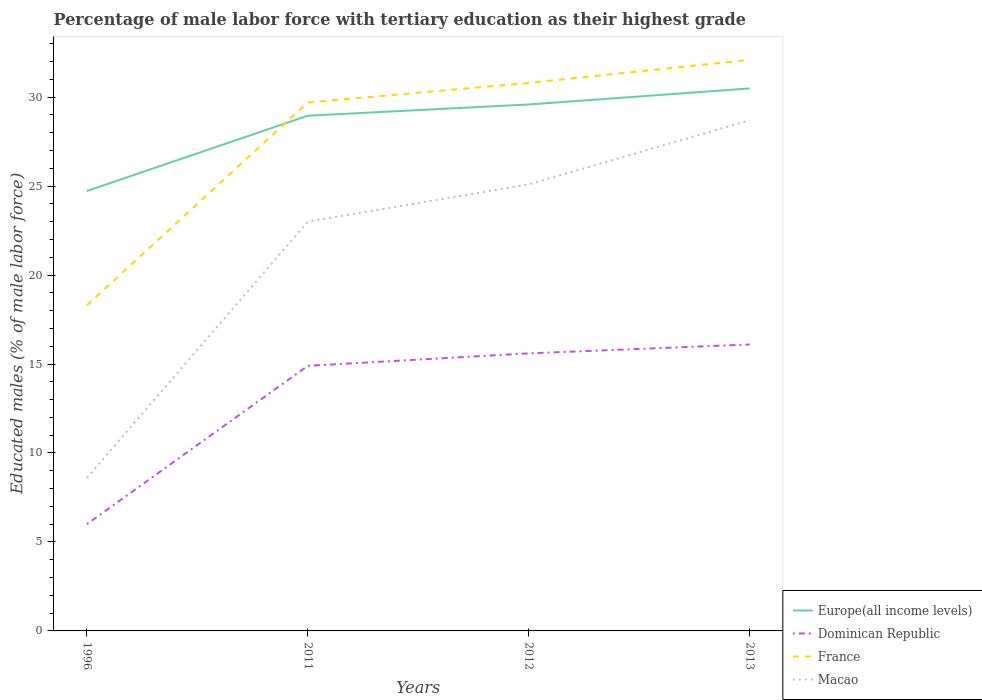Does the line corresponding to Dominican Republic intersect with the line corresponding to France?
Your answer should be compact. No. Across all years, what is the maximum percentage of male labor force with tertiary education in Europe(all income levels)?
Give a very brief answer. 24.72. What is the total percentage of male labor force with tertiary education in France in the graph?
Offer a very short reply. -1.3. What is the difference between the highest and the second highest percentage of male labor force with tertiary education in Dominican Republic?
Your answer should be very brief. 10.1. Is the percentage of male labor force with tertiary education in Dominican Republic strictly greater than the percentage of male labor force with tertiary education in Europe(all income levels) over the years?
Provide a short and direct response. Yes. How many lines are there?
Your answer should be very brief. 4. How many years are there in the graph?
Provide a short and direct response. 4. What is the difference between two consecutive major ticks on the Y-axis?
Your answer should be very brief. 5. Are the values on the major ticks of Y-axis written in scientific E-notation?
Provide a succinct answer. No. Does the graph contain any zero values?
Make the answer very short. No. Where does the legend appear in the graph?
Your answer should be very brief. Bottom right. How many legend labels are there?
Provide a short and direct response. 4. How are the legend labels stacked?
Offer a very short reply. Vertical. What is the title of the graph?
Offer a very short reply. Percentage of male labor force with tertiary education as their highest grade. What is the label or title of the Y-axis?
Your answer should be very brief. Educated males (% of male labor force). What is the Educated males (% of male labor force) in Europe(all income levels) in 1996?
Keep it short and to the point. 24.72. What is the Educated males (% of male labor force) of France in 1996?
Make the answer very short. 18.3. What is the Educated males (% of male labor force) of Macao in 1996?
Make the answer very short. 8.6. What is the Educated males (% of male labor force) in Europe(all income levels) in 2011?
Offer a terse response. 28.96. What is the Educated males (% of male labor force) of Dominican Republic in 2011?
Offer a very short reply. 14.9. What is the Educated males (% of male labor force) in France in 2011?
Provide a succinct answer. 29.7. What is the Educated males (% of male labor force) in Europe(all income levels) in 2012?
Provide a short and direct response. 29.59. What is the Educated males (% of male labor force) in Dominican Republic in 2012?
Your answer should be very brief. 15.6. What is the Educated males (% of male labor force) in France in 2012?
Offer a terse response. 30.8. What is the Educated males (% of male labor force) of Macao in 2012?
Make the answer very short. 25.1. What is the Educated males (% of male labor force) of Europe(all income levels) in 2013?
Your answer should be compact. 30.49. What is the Educated males (% of male labor force) of Dominican Republic in 2013?
Make the answer very short. 16.1. What is the Educated males (% of male labor force) in France in 2013?
Provide a succinct answer. 32.1. What is the Educated males (% of male labor force) in Macao in 2013?
Offer a terse response. 28.7. Across all years, what is the maximum Educated males (% of male labor force) of Europe(all income levels)?
Provide a short and direct response. 30.49. Across all years, what is the maximum Educated males (% of male labor force) of Dominican Republic?
Keep it short and to the point. 16.1. Across all years, what is the maximum Educated males (% of male labor force) of France?
Ensure brevity in your answer.  32.1. Across all years, what is the maximum Educated males (% of male labor force) in Macao?
Your response must be concise. 28.7. Across all years, what is the minimum Educated males (% of male labor force) of Europe(all income levels)?
Make the answer very short. 24.72. Across all years, what is the minimum Educated males (% of male labor force) of France?
Make the answer very short. 18.3. Across all years, what is the minimum Educated males (% of male labor force) of Macao?
Ensure brevity in your answer.  8.6. What is the total Educated males (% of male labor force) in Europe(all income levels) in the graph?
Ensure brevity in your answer.  113.76. What is the total Educated males (% of male labor force) in Dominican Republic in the graph?
Ensure brevity in your answer.  52.6. What is the total Educated males (% of male labor force) in France in the graph?
Your response must be concise. 110.9. What is the total Educated males (% of male labor force) of Macao in the graph?
Offer a terse response. 85.4. What is the difference between the Educated males (% of male labor force) of Europe(all income levels) in 1996 and that in 2011?
Your answer should be compact. -4.23. What is the difference between the Educated males (% of male labor force) in France in 1996 and that in 2011?
Offer a very short reply. -11.4. What is the difference between the Educated males (% of male labor force) in Macao in 1996 and that in 2011?
Make the answer very short. -14.4. What is the difference between the Educated males (% of male labor force) of Europe(all income levels) in 1996 and that in 2012?
Your response must be concise. -4.87. What is the difference between the Educated males (% of male labor force) in Dominican Republic in 1996 and that in 2012?
Offer a terse response. -9.6. What is the difference between the Educated males (% of male labor force) of Macao in 1996 and that in 2012?
Your answer should be compact. -16.5. What is the difference between the Educated males (% of male labor force) of Europe(all income levels) in 1996 and that in 2013?
Your response must be concise. -5.76. What is the difference between the Educated males (% of male labor force) of Dominican Republic in 1996 and that in 2013?
Provide a short and direct response. -10.1. What is the difference between the Educated males (% of male labor force) in Macao in 1996 and that in 2013?
Keep it short and to the point. -20.1. What is the difference between the Educated males (% of male labor force) in Europe(all income levels) in 2011 and that in 2012?
Your answer should be compact. -0.63. What is the difference between the Educated males (% of male labor force) of Dominican Republic in 2011 and that in 2012?
Your response must be concise. -0.7. What is the difference between the Educated males (% of male labor force) in Macao in 2011 and that in 2012?
Keep it short and to the point. -2.1. What is the difference between the Educated males (% of male labor force) of Europe(all income levels) in 2011 and that in 2013?
Give a very brief answer. -1.53. What is the difference between the Educated males (% of male labor force) in Europe(all income levels) in 2012 and that in 2013?
Provide a succinct answer. -0.9. What is the difference between the Educated males (% of male labor force) in Dominican Republic in 2012 and that in 2013?
Make the answer very short. -0.5. What is the difference between the Educated males (% of male labor force) in Europe(all income levels) in 1996 and the Educated males (% of male labor force) in Dominican Republic in 2011?
Your response must be concise. 9.82. What is the difference between the Educated males (% of male labor force) of Europe(all income levels) in 1996 and the Educated males (% of male labor force) of France in 2011?
Your response must be concise. -4.98. What is the difference between the Educated males (% of male labor force) in Europe(all income levels) in 1996 and the Educated males (% of male labor force) in Macao in 2011?
Provide a short and direct response. 1.72. What is the difference between the Educated males (% of male labor force) of Dominican Republic in 1996 and the Educated males (% of male labor force) of France in 2011?
Your answer should be compact. -23.7. What is the difference between the Educated males (% of male labor force) in Dominican Republic in 1996 and the Educated males (% of male labor force) in Macao in 2011?
Your response must be concise. -17. What is the difference between the Educated males (% of male labor force) in France in 1996 and the Educated males (% of male labor force) in Macao in 2011?
Ensure brevity in your answer.  -4.7. What is the difference between the Educated males (% of male labor force) of Europe(all income levels) in 1996 and the Educated males (% of male labor force) of Dominican Republic in 2012?
Keep it short and to the point. 9.12. What is the difference between the Educated males (% of male labor force) of Europe(all income levels) in 1996 and the Educated males (% of male labor force) of France in 2012?
Your response must be concise. -6.08. What is the difference between the Educated males (% of male labor force) of Europe(all income levels) in 1996 and the Educated males (% of male labor force) of Macao in 2012?
Your response must be concise. -0.38. What is the difference between the Educated males (% of male labor force) in Dominican Republic in 1996 and the Educated males (% of male labor force) in France in 2012?
Give a very brief answer. -24.8. What is the difference between the Educated males (% of male labor force) of Dominican Republic in 1996 and the Educated males (% of male labor force) of Macao in 2012?
Give a very brief answer. -19.1. What is the difference between the Educated males (% of male labor force) of Europe(all income levels) in 1996 and the Educated males (% of male labor force) of Dominican Republic in 2013?
Your answer should be compact. 8.62. What is the difference between the Educated males (% of male labor force) in Europe(all income levels) in 1996 and the Educated males (% of male labor force) in France in 2013?
Provide a succinct answer. -7.38. What is the difference between the Educated males (% of male labor force) of Europe(all income levels) in 1996 and the Educated males (% of male labor force) of Macao in 2013?
Offer a very short reply. -3.98. What is the difference between the Educated males (% of male labor force) of Dominican Republic in 1996 and the Educated males (% of male labor force) of France in 2013?
Your answer should be very brief. -26.1. What is the difference between the Educated males (% of male labor force) in Dominican Republic in 1996 and the Educated males (% of male labor force) in Macao in 2013?
Provide a succinct answer. -22.7. What is the difference between the Educated males (% of male labor force) in France in 1996 and the Educated males (% of male labor force) in Macao in 2013?
Offer a terse response. -10.4. What is the difference between the Educated males (% of male labor force) in Europe(all income levels) in 2011 and the Educated males (% of male labor force) in Dominican Republic in 2012?
Keep it short and to the point. 13.36. What is the difference between the Educated males (% of male labor force) in Europe(all income levels) in 2011 and the Educated males (% of male labor force) in France in 2012?
Offer a very short reply. -1.84. What is the difference between the Educated males (% of male labor force) of Europe(all income levels) in 2011 and the Educated males (% of male labor force) of Macao in 2012?
Offer a terse response. 3.86. What is the difference between the Educated males (% of male labor force) in Dominican Republic in 2011 and the Educated males (% of male labor force) in France in 2012?
Offer a very short reply. -15.9. What is the difference between the Educated males (% of male labor force) of Dominican Republic in 2011 and the Educated males (% of male labor force) of Macao in 2012?
Provide a succinct answer. -10.2. What is the difference between the Educated males (% of male labor force) in France in 2011 and the Educated males (% of male labor force) in Macao in 2012?
Offer a very short reply. 4.6. What is the difference between the Educated males (% of male labor force) of Europe(all income levels) in 2011 and the Educated males (% of male labor force) of Dominican Republic in 2013?
Your answer should be compact. 12.86. What is the difference between the Educated males (% of male labor force) in Europe(all income levels) in 2011 and the Educated males (% of male labor force) in France in 2013?
Give a very brief answer. -3.14. What is the difference between the Educated males (% of male labor force) in Europe(all income levels) in 2011 and the Educated males (% of male labor force) in Macao in 2013?
Make the answer very short. 0.26. What is the difference between the Educated males (% of male labor force) in Dominican Republic in 2011 and the Educated males (% of male labor force) in France in 2013?
Offer a very short reply. -17.2. What is the difference between the Educated males (% of male labor force) in Dominican Republic in 2011 and the Educated males (% of male labor force) in Macao in 2013?
Ensure brevity in your answer.  -13.8. What is the difference between the Educated males (% of male labor force) of France in 2011 and the Educated males (% of male labor force) of Macao in 2013?
Your answer should be compact. 1. What is the difference between the Educated males (% of male labor force) in Europe(all income levels) in 2012 and the Educated males (% of male labor force) in Dominican Republic in 2013?
Offer a terse response. 13.49. What is the difference between the Educated males (% of male labor force) of Europe(all income levels) in 2012 and the Educated males (% of male labor force) of France in 2013?
Offer a very short reply. -2.51. What is the difference between the Educated males (% of male labor force) in Europe(all income levels) in 2012 and the Educated males (% of male labor force) in Macao in 2013?
Your answer should be very brief. 0.89. What is the difference between the Educated males (% of male labor force) in Dominican Republic in 2012 and the Educated males (% of male labor force) in France in 2013?
Give a very brief answer. -16.5. What is the difference between the Educated males (% of male labor force) of Dominican Republic in 2012 and the Educated males (% of male labor force) of Macao in 2013?
Your answer should be compact. -13.1. What is the average Educated males (% of male labor force) of Europe(all income levels) per year?
Offer a terse response. 28.44. What is the average Educated males (% of male labor force) of Dominican Republic per year?
Provide a short and direct response. 13.15. What is the average Educated males (% of male labor force) of France per year?
Give a very brief answer. 27.73. What is the average Educated males (% of male labor force) in Macao per year?
Give a very brief answer. 21.35. In the year 1996, what is the difference between the Educated males (% of male labor force) in Europe(all income levels) and Educated males (% of male labor force) in Dominican Republic?
Your answer should be very brief. 18.72. In the year 1996, what is the difference between the Educated males (% of male labor force) in Europe(all income levels) and Educated males (% of male labor force) in France?
Your answer should be very brief. 6.42. In the year 1996, what is the difference between the Educated males (% of male labor force) of Europe(all income levels) and Educated males (% of male labor force) of Macao?
Ensure brevity in your answer.  16.12. In the year 1996, what is the difference between the Educated males (% of male labor force) of France and Educated males (% of male labor force) of Macao?
Provide a succinct answer. 9.7. In the year 2011, what is the difference between the Educated males (% of male labor force) of Europe(all income levels) and Educated males (% of male labor force) of Dominican Republic?
Ensure brevity in your answer.  14.06. In the year 2011, what is the difference between the Educated males (% of male labor force) of Europe(all income levels) and Educated males (% of male labor force) of France?
Provide a short and direct response. -0.74. In the year 2011, what is the difference between the Educated males (% of male labor force) in Europe(all income levels) and Educated males (% of male labor force) in Macao?
Offer a very short reply. 5.96. In the year 2011, what is the difference between the Educated males (% of male labor force) of Dominican Republic and Educated males (% of male labor force) of France?
Offer a terse response. -14.8. In the year 2011, what is the difference between the Educated males (% of male labor force) in Dominican Republic and Educated males (% of male labor force) in Macao?
Offer a very short reply. -8.1. In the year 2011, what is the difference between the Educated males (% of male labor force) in France and Educated males (% of male labor force) in Macao?
Ensure brevity in your answer.  6.7. In the year 2012, what is the difference between the Educated males (% of male labor force) in Europe(all income levels) and Educated males (% of male labor force) in Dominican Republic?
Provide a short and direct response. 13.99. In the year 2012, what is the difference between the Educated males (% of male labor force) in Europe(all income levels) and Educated males (% of male labor force) in France?
Your response must be concise. -1.21. In the year 2012, what is the difference between the Educated males (% of male labor force) of Europe(all income levels) and Educated males (% of male labor force) of Macao?
Ensure brevity in your answer.  4.49. In the year 2012, what is the difference between the Educated males (% of male labor force) in Dominican Republic and Educated males (% of male labor force) in France?
Offer a very short reply. -15.2. In the year 2013, what is the difference between the Educated males (% of male labor force) of Europe(all income levels) and Educated males (% of male labor force) of Dominican Republic?
Give a very brief answer. 14.39. In the year 2013, what is the difference between the Educated males (% of male labor force) in Europe(all income levels) and Educated males (% of male labor force) in France?
Your answer should be very brief. -1.61. In the year 2013, what is the difference between the Educated males (% of male labor force) of Europe(all income levels) and Educated males (% of male labor force) of Macao?
Ensure brevity in your answer.  1.79. In the year 2013, what is the difference between the Educated males (% of male labor force) of Dominican Republic and Educated males (% of male labor force) of France?
Offer a very short reply. -16. In the year 2013, what is the difference between the Educated males (% of male labor force) in Dominican Republic and Educated males (% of male labor force) in Macao?
Give a very brief answer. -12.6. What is the ratio of the Educated males (% of male labor force) of Europe(all income levels) in 1996 to that in 2011?
Offer a terse response. 0.85. What is the ratio of the Educated males (% of male labor force) of Dominican Republic in 1996 to that in 2011?
Ensure brevity in your answer.  0.4. What is the ratio of the Educated males (% of male labor force) of France in 1996 to that in 2011?
Your answer should be compact. 0.62. What is the ratio of the Educated males (% of male labor force) in Macao in 1996 to that in 2011?
Ensure brevity in your answer.  0.37. What is the ratio of the Educated males (% of male labor force) of Europe(all income levels) in 1996 to that in 2012?
Ensure brevity in your answer.  0.84. What is the ratio of the Educated males (% of male labor force) in Dominican Republic in 1996 to that in 2012?
Your answer should be compact. 0.38. What is the ratio of the Educated males (% of male labor force) in France in 1996 to that in 2012?
Give a very brief answer. 0.59. What is the ratio of the Educated males (% of male labor force) of Macao in 1996 to that in 2012?
Offer a very short reply. 0.34. What is the ratio of the Educated males (% of male labor force) of Europe(all income levels) in 1996 to that in 2013?
Offer a terse response. 0.81. What is the ratio of the Educated males (% of male labor force) in Dominican Republic in 1996 to that in 2013?
Give a very brief answer. 0.37. What is the ratio of the Educated males (% of male labor force) in France in 1996 to that in 2013?
Give a very brief answer. 0.57. What is the ratio of the Educated males (% of male labor force) of Macao in 1996 to that in 2013?
Offer a very short reply. 0.3. What is the ratio of the Educated males (% of male labor force) in Europe(all income levels) in 2011 to that in 2012?
Offer a terse response. 0.98. What is the ratio of the Educated males (% of male labor force) in Dominican Republic in 2011 to that in 2012?
Your response must be concise. 0.96. What is the ratio of the Educated males (% of male labor force) of France in 2011 to that in 2012?
Give a very brief answer. 0.96. What is the ratio of the Educated males (% of male labor force) in Macao in 2011 to that in 2012?
Provide a succinct answer. 0.92. What is the ratio of the Educated males (% of male labor force) of Europe(all income levels) in 2011 to that in 2013?
Provide a succinct answer. 0.95. What is the ratio of the Educated males (% of male labor force) in Dominican Republic in 2011 to that in 2013?
Give a very brief answer. 0.93. What is the ratio of the Educated males (% of male labor force) of France in 2011 to that in 2013?
Ensure brevity in your answer.  0.93. What is the ratio of the Educated males (% of male labor force) in Macao in 2011 to that in 2013?
Keep it short and to the point. 0.8. What is the ratio of the Educated males (% of male labor force) in Europe(all income levels) in 2012 to that in 2013?
Provide a short and direct response. 0.97. What is the ratio of the Educated males (% of male labor force) in Dominican Republic in 2012 to that in 2013?
Keep it short and to the point. 0.97. What is the ratio of the Educated males (% of male labor force) of France in 2012 to that in 2013?
Make the answer very short. 0.96. What is the ratio of the Educated males (% of male labor force) in Macao in 2012 to that in 2013?
Offer a terse response. 0.87. What is the difference between the highest and the second highest Educated males (% of male labor force) in Europe(all income levels)?
Provide a succinct answer. 0.9. What is the difference between the highest and the second highest Educated males (% of male labor force) in Dominican Republic?
Your response must be concise. 0.5. What is the difference between the highest and the second highest Educated males (% of male labor force) in Macao?
Give a very brief answer. 3.6. What is the difference between the highest and the lowest Educated males (% of male labor force) in Europe(all income levels)?
Give a very brief answer. 5.76. What is the difference between the highest and the lowest Educated males (% of male labor force) in Macao?
Provide a short and direct response. 20.1. 